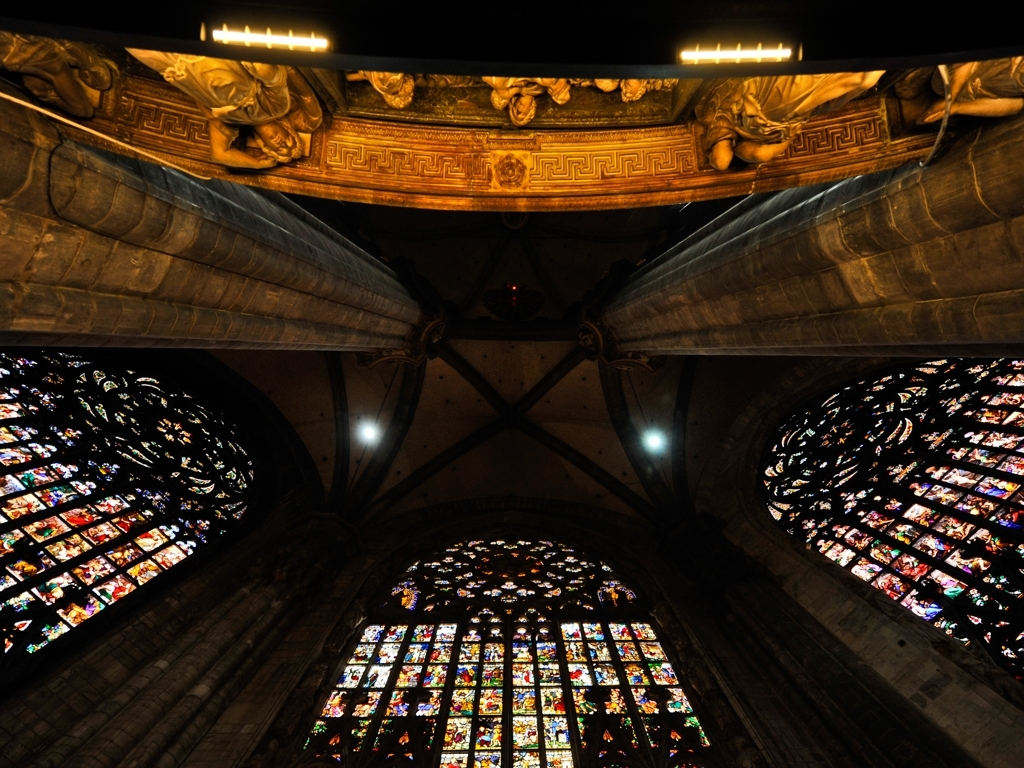Can you tell me about the time period this photo might represent? Considering the Gothic architectural elements, such as the rose windows, ribbed vaults, and the ornate stonework, this photo likely represents a scene from the late medieval era, roughly between the 12th and 16th centuries, when Gothic architecture was predominant in Europe. 